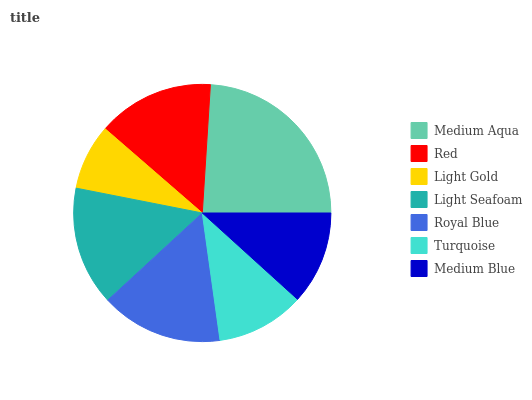Is Light Gold the minimum?
Answer yes or no. Yes. Is Medium Aqua the maximum?
Answer yes or no. Yes. Is Red the minimum?
Answer yes or no. No. Is Red the maximum?
Answer yes or no. No. Is Medium Aqua greater than Red?
Answer yes or no. Yes. Is Red less than Medium Aqua?
Answer yes or no. Yes. Is Red greater than Medium Aqua?
Answer yes or no. No. Is Medium Aqua less than Red?
Answer yes or no. No. Is Red the high median?
Answer yes or no. Yes. Is Red the low median?
Answer yes or no. Yes. Is Turquoise the high median?
Answer yes or no. No. Is Turquoise the low median?
Answer yes or no. No. 